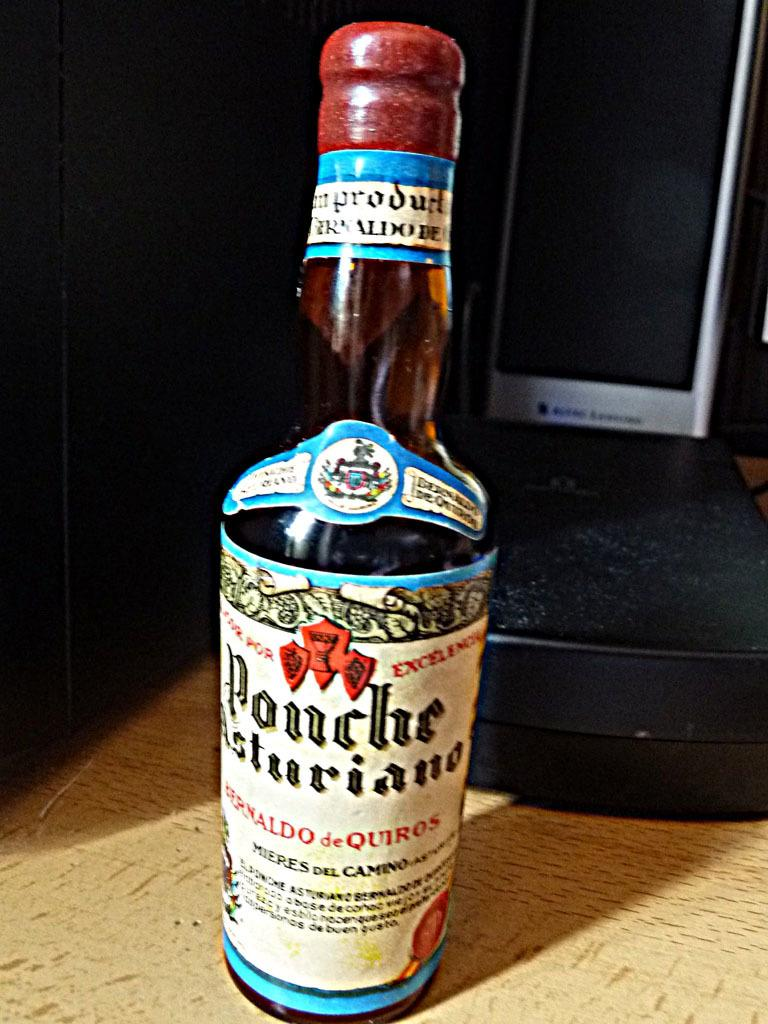<image>
Share a concise interpretation of the image provided. a bottle of ponche asturiano with a white label on it 